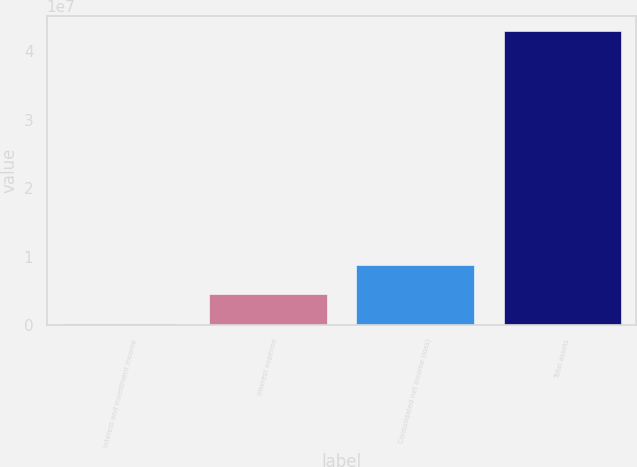<chart> <loc_0><loc_0><loc_500><loc_500><bar_chart><fcel>Interest and investment income<fcel>Interest expense<fcel>Consolidated net income (loss)<fcel>Total assets<nl><fcel>218317<fcel>4.49435e+06<fcel>8.77039e+06<fcel>4.29787e+07<nl></chart> 